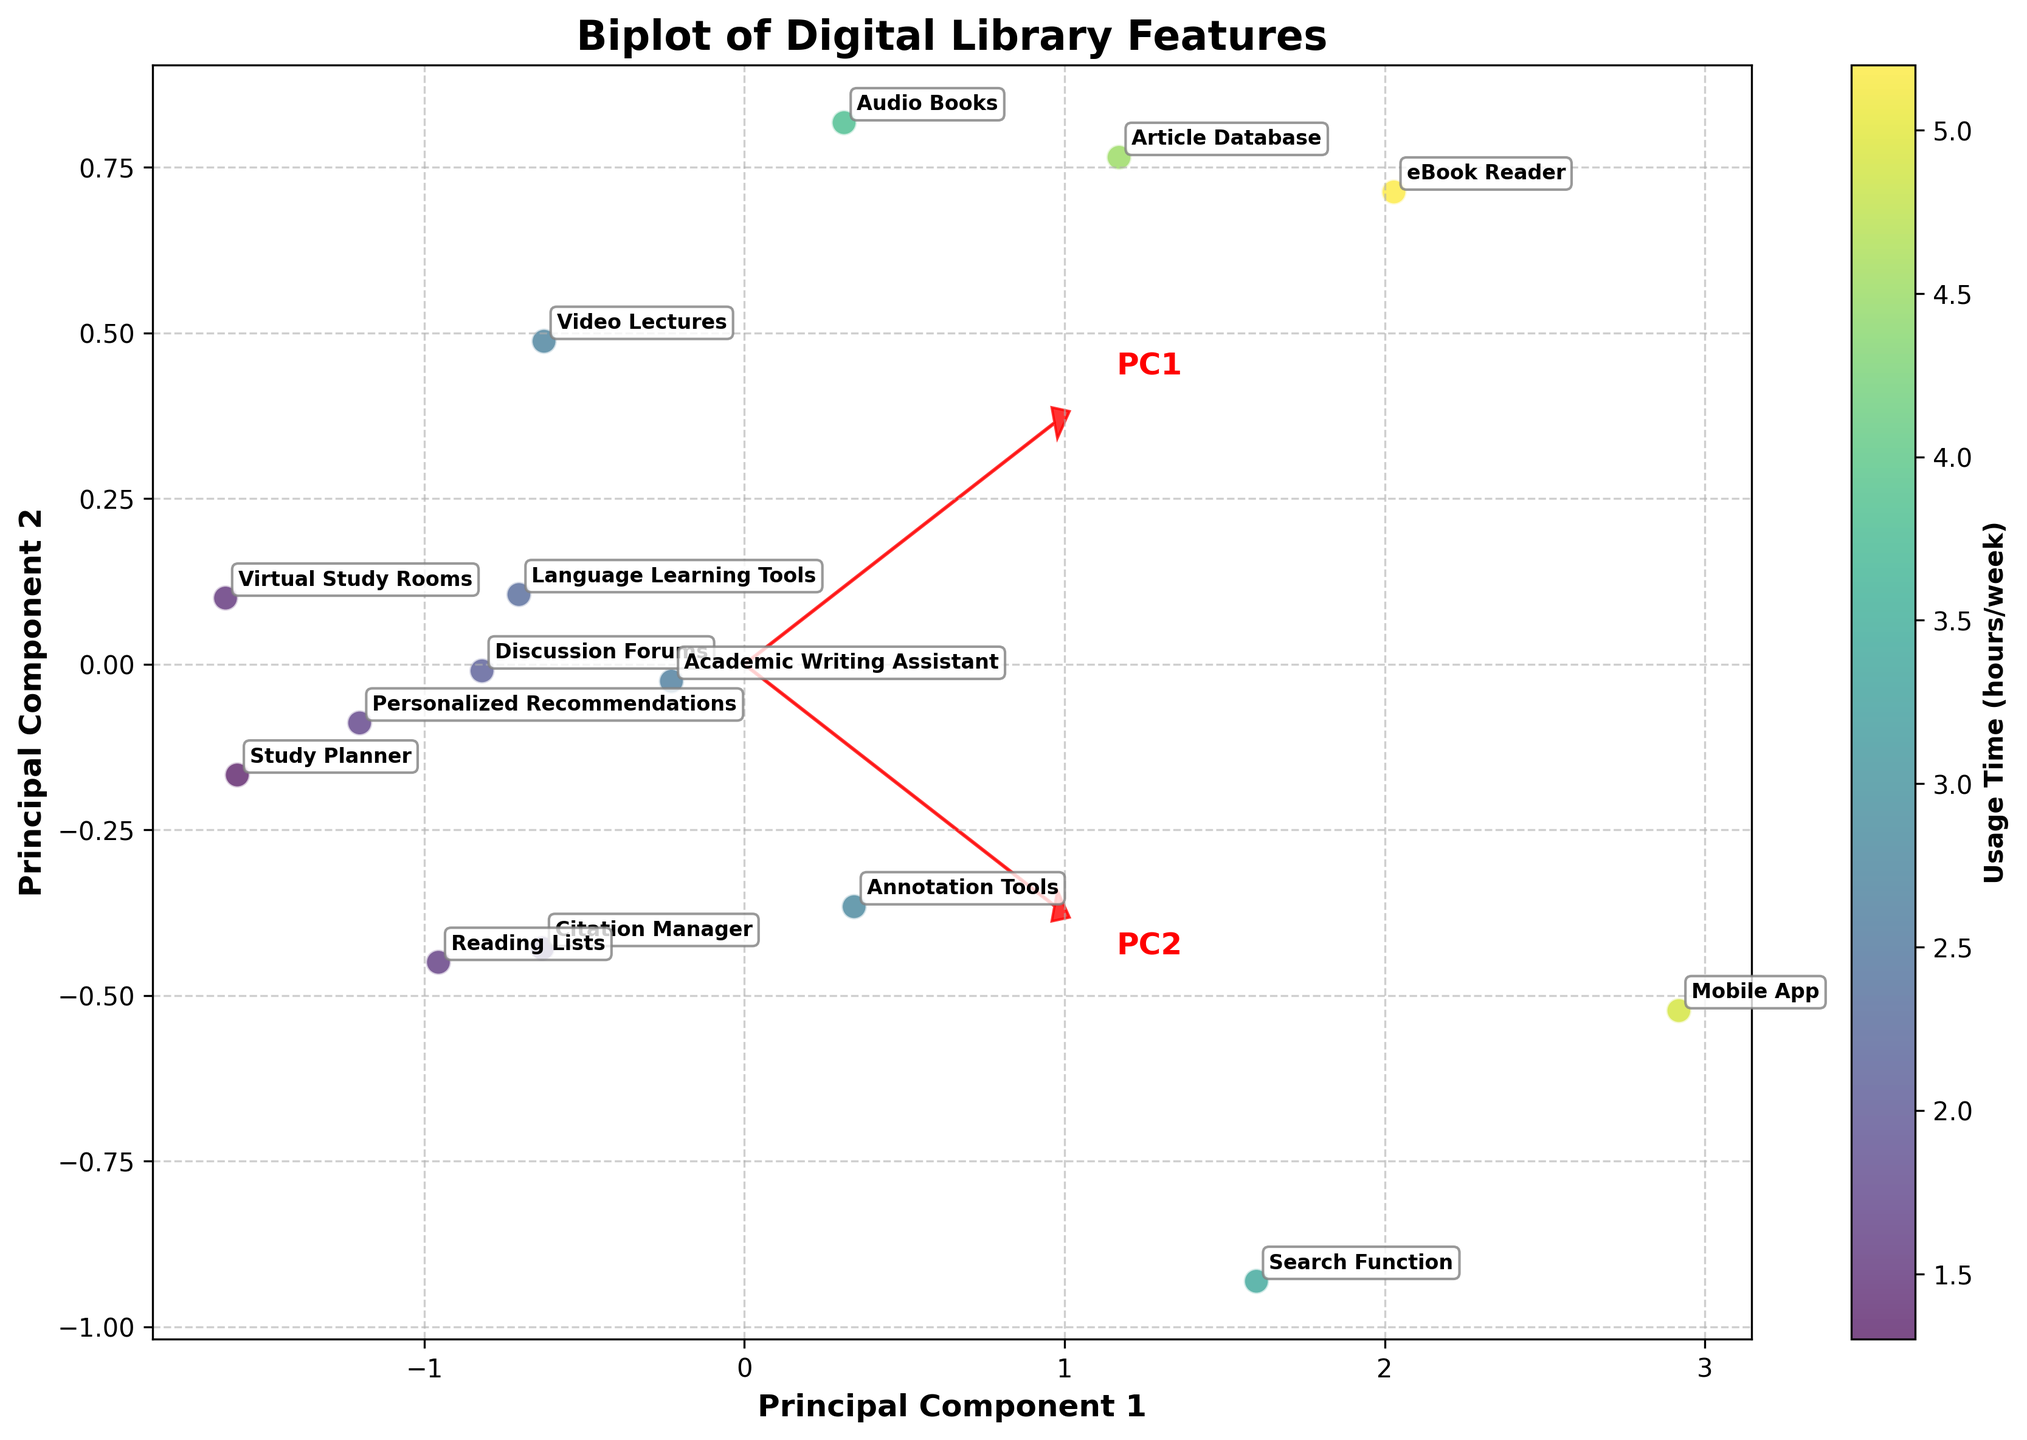How many features are included in the biplot? Count the number of distinct annotated feature names appearing in the biplot.
Answer: 15 What is the feature with the highest access frequency? Look for the point farthest to the right on the axis labeled 'Access Frequency (times/week)'. The highest value is represented by the most rightward point.
Answer: Mobile App Which feature has the lowest usage time? Find the feature point closest to the bottom of the axis labeled 'Usage Time (hours/week)'. The lowest value corresponds to the bottom-most point.
Answer: Study Planner Compare the usage time and access frequency between the 'eBook Reader' and 'Article Database'. Which one is more frequently accessed? Locate the positions of 'eBook Reader' and 'Article Database' in terms of access frequency. The feature further to the right has a higher access frequency.
Answer: eBook Reader Which principal component explains more variance in the data, PC1 or PC2? Look at the plot to determine the direction and length of the eigenvectors. The longer arrow generally denotes the principal component explaining more variance.
Answer: PC1 What is the average usage time of the features that have an access frequency above 10 times/week? Identify the features with access frequency greater than 10, sum their usage times, and divide by the number of such features. These features are 'eBook Reader', 'Article Database', 'Annotation Tools', 'Search Function', and 'Mobile App'. (5.2 + 4.5 + 2.8 + 3.4 + 4.9) / 5 = 4.16
Answer: 4.16 hours/week Which features have higher usage time but relatively lower access frequency compared to 'Audio Books'? Find features with a usage time longer than 3.8 hours/week but an access frequency below 8 times/week.
Answer: None What is the relation between 'Usage Time' and 'Access Frequency' depicted by the eigenvectors in the biplot? The direction and angle of the eigenvectors indicate the correlation between the two variables. If they point in similar directions, they are positively correlated; if they are perpendicular, there is weak or no correlation.
Answer: Positively correlated How does 'Video Lectures' compare to 'Language Learning Tools' in terms of both usage time and access frequency? Compare their positions on both axes: Usage Time and Access Frequency. 'Video Lectures' has a lower usage time (2.7 vs. 2.3) and lower access frequency (6 vs. 7).
Answer: 'Language Learning Tools' has higher access frequency 